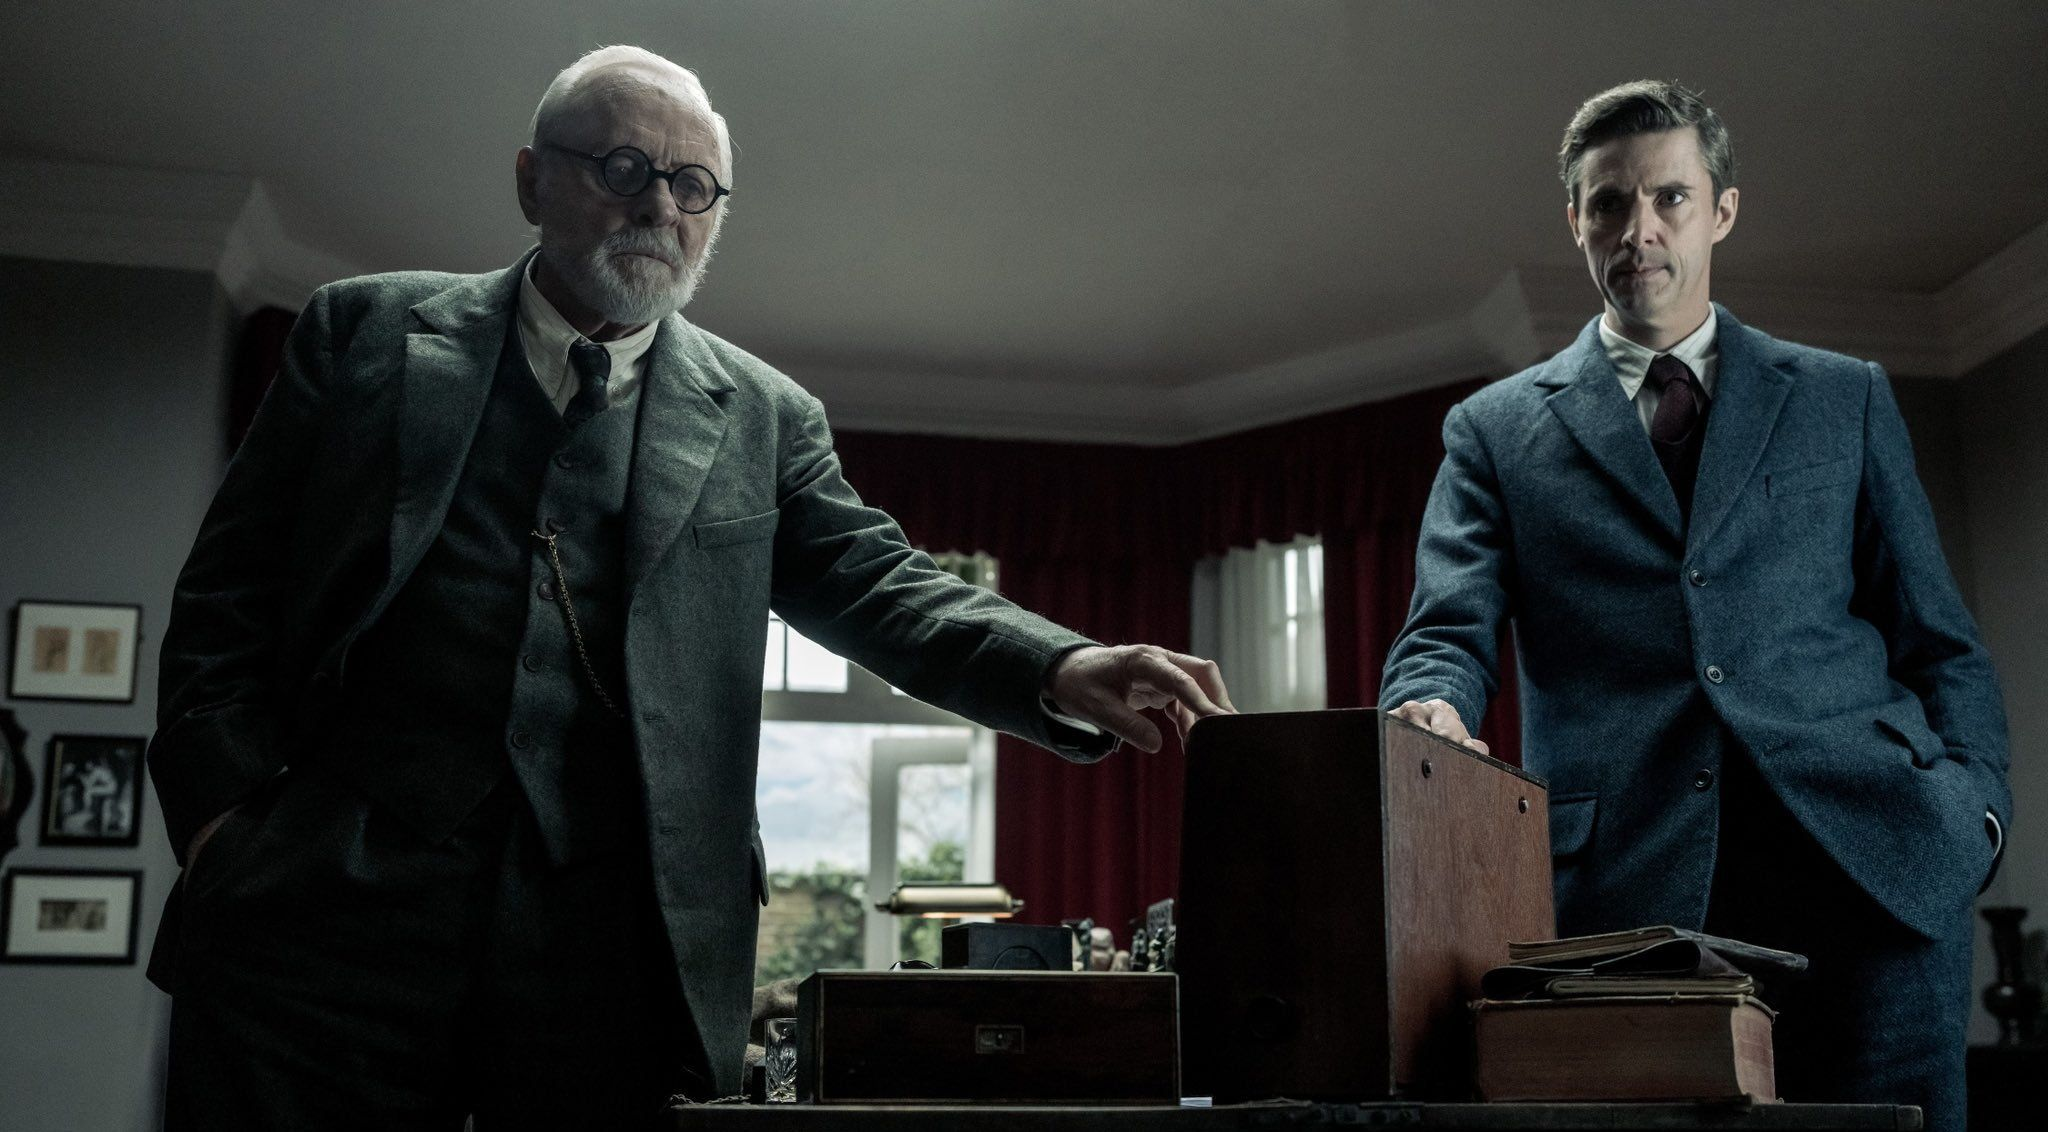Create a backstory for the two characters in the scene based on their appearance and the setting. The elderly man, perhaps a seasoned detective or a scholar, is engaged in a heated discussion with the younger man, who could be a junior colleague or an antagonist. The room, adorned with red curtains and framed pictures, might be the elderly man's office, filled with years of achievements and mysteries. The box on the table could be a piece of critical evidence or an artifact that could solve a long-standing mystery or lead to a significant breakthrough. 